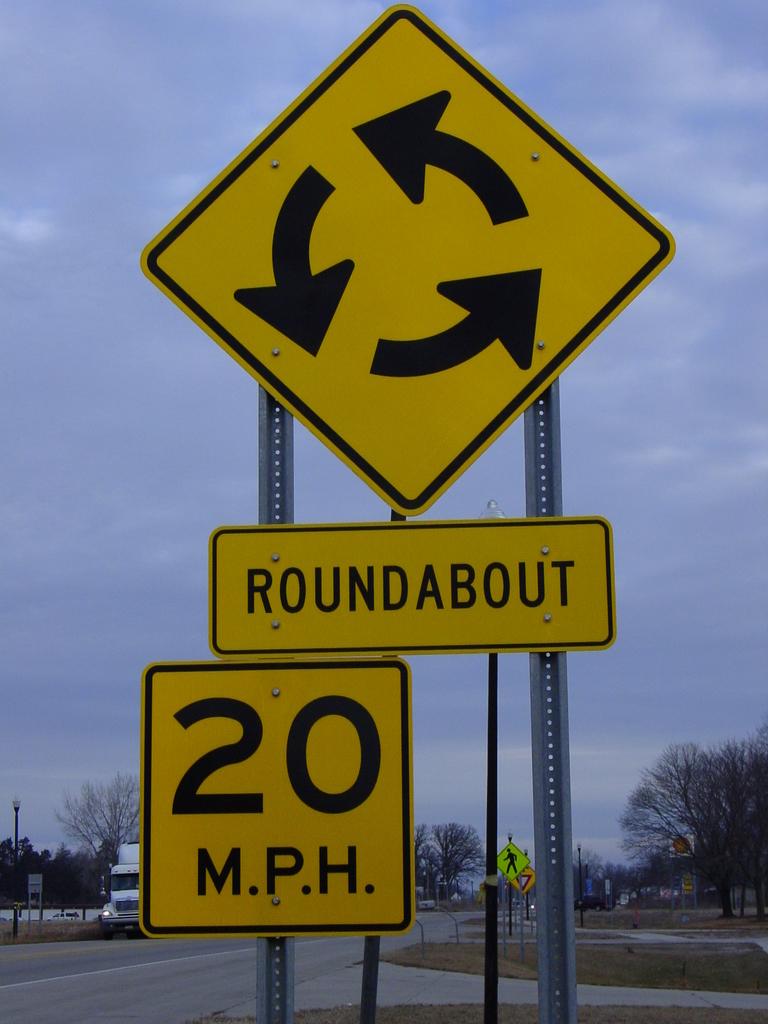What is the speed limit of this road?
Make the answer very short. 20 mph. What does it say above the speed limit?
Offer a very short reply. Roundabout. 